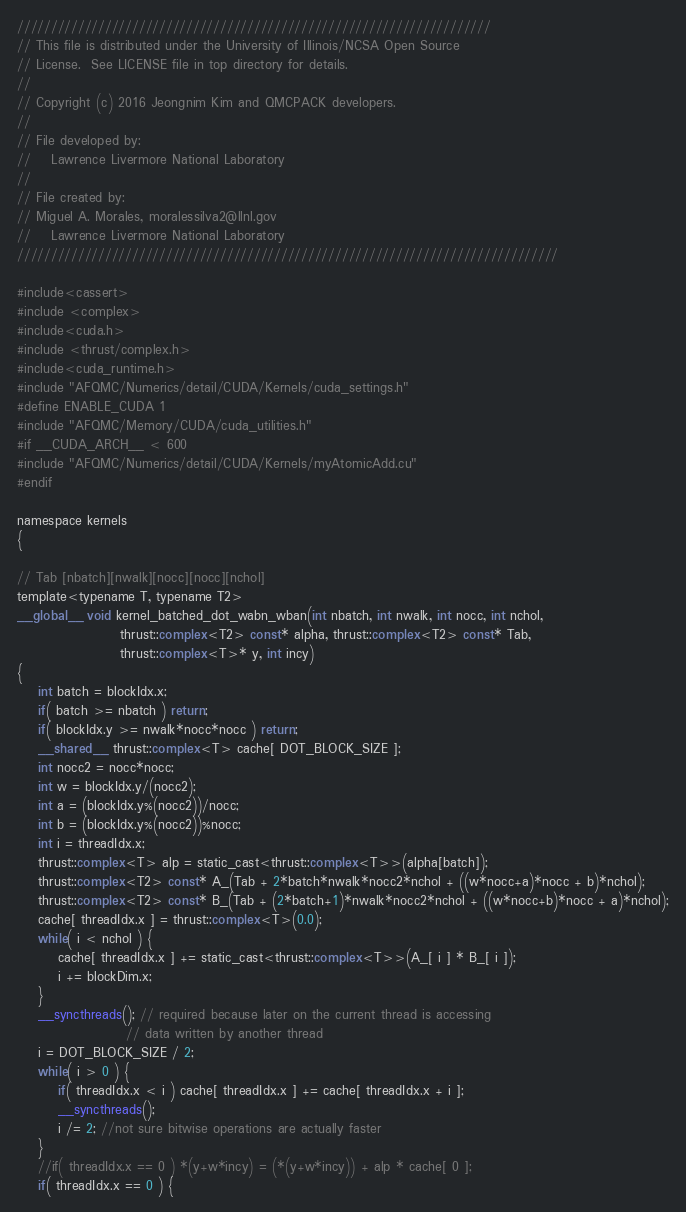<code> <loc_0><loc_0><loc_500><loc_500><_Cuda_>//////////////////////////////////////////////////////////////////////
// This file is distributed under the University of Illinois/NCSA Open Source
// License.  See LICENSE file in top directory for details.
//
// Copyright (c) 2016 Jeongnim Kim and QMCPACK developers.
//
// File developed by:
//    Lawrence Livermore National Laboratory 
//
// File created by:
// Miguel A. Morales, moralessilva2@llnl.gov 
//    Lawrence Livermore National Laboratory 
////////////////////////////////////////////////////////////////////////////////

#include<cassert>
#include <complex>
#include<cuda.h>
#include <thrust/complex.h>
#include<cuda_runtime.h>
#include "AFQMC/Numerics/detail/CUDA/Kernels/cuda_settings.h"
#define ENABLE_CUDA 1
#include "AFQMC/Memory/CUDA/cuda_utilities.h"
#if __CUDA_ARCH__ < 600
#include "AFQMC/Numerics/detail/CUDA/Kernels/myAtomicAdd.cu"
#endif

namespace kernels 
{

// Tab [nbatch][nwalk][nocc][nocc][nchol]
template<typename T, typename T2>
__global__ void kernel_batched_dot_wabn_wban(int nbatch, int nwalk, int nocc, int nchol,
                    thrust::complex<T2> const* alpha, thrust::complex<T2> const* Tab, 
                    thrust::complex<T>* y, int incy)
{
    int batch = blockIdx.x;
    if( batch >= nbatch ) return;
    if( blockIdx.y >= nwalk*nocc*nocc ) return;
    __shared__ thrust::complex<T> cache[ DOT_BLOCK_SIZE ];
    int nocc2 = nocc*nocc;
    int w = blockIdx.y/(nocc2);
    int a = (blockIdx.y%(nocc2))/nocc;
    int b = (blockIdx.y%(nocc2))%nocc;
    int i = threadIdx.x;
    thrust::complex<T> alp = static_cast<thrust::complex<T>>(alpha[batch]);
    thrust::complex<T2> const* A_(Tab + 2*batch*nwalk*nocc2*nchol + ((w*nocc+a)*nocc + b)*nchol);
    thrust::complex<T2> const* B_(Tab + (2*batch+1)*nwalk*nocc2*nchol + ((w*nocc+b)*nocc + a)*nchol);
    cache[ threadIdx.x ] = thrust::complex<T>(0.0);
    while( i < nchol ) {
        cache[ threadIdx.x ] += static_cast<thrust::complex<T>>(A_[ i ] * B_[ i ]);
        i += blockDim.x;
    }
    __syncthreads(); // required because later on the current thread is accessing
                     // data written by another thread    
    i = DOT_BLOCK_SIZE / 2;
    while( i > 0 ) {
        if( threadIdx.x < i ) cache[ threadIdx.x ] += cache[ threadIdx.x + i ];
        __syncthreads();
        i /= 2; //not sure bitwise operations are actually faster
    }
    //if( threadIdx.x == 0 ) *(y+w*incy) = (*(y+w*incy)) + alp * cache[ 0 ];
    if( threadIdx.x == 0 ) {</code> 